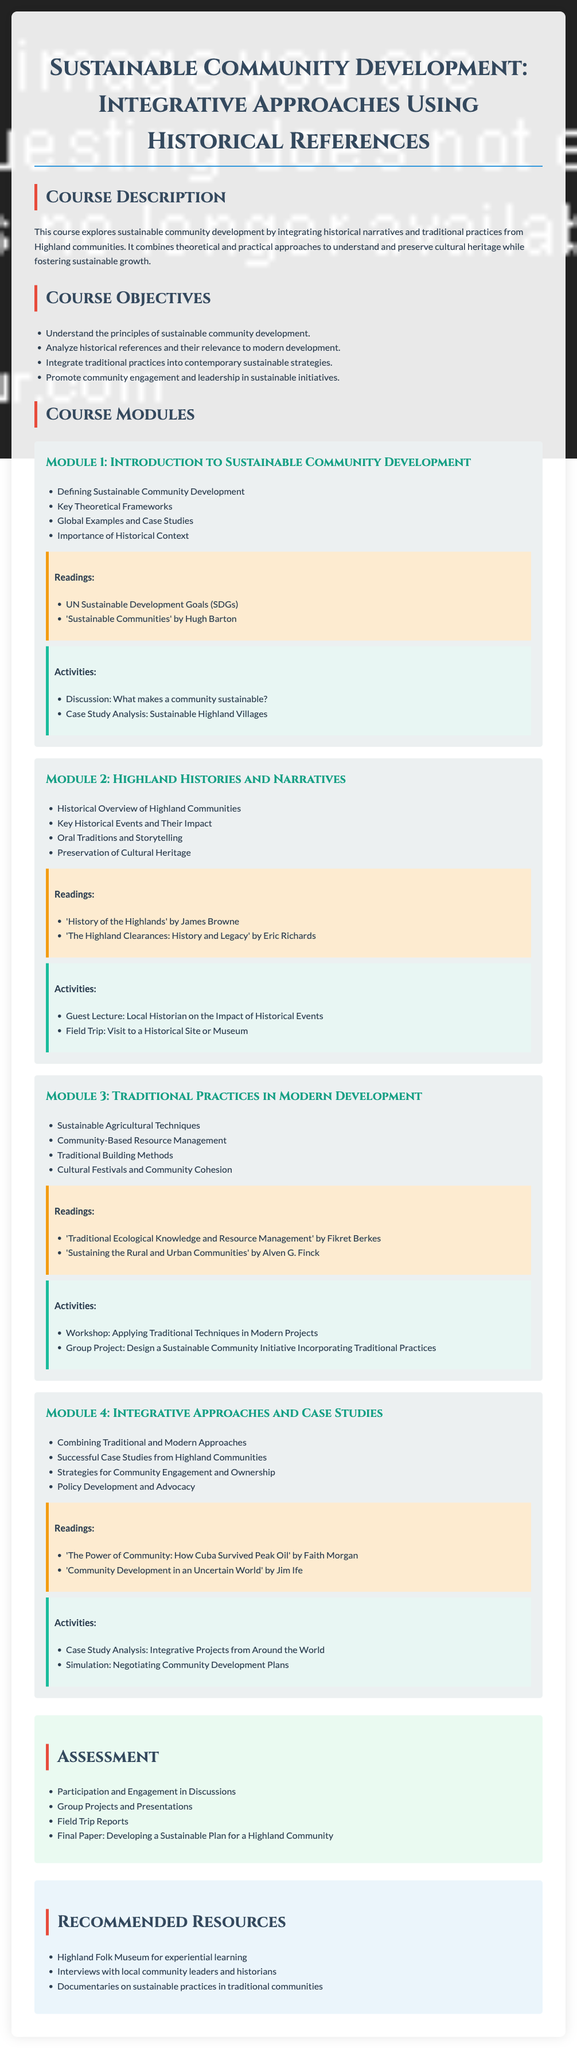What is the title of the course? The title of the course is stated prominently at the beginning of the document.
Answer: Sustainable Community Development: Integrative Approaches Using Historical References How many modules are in the course? The document lists the modules under Course Modules, and counts them.
Answer: Four Who is the author of "History of the Highlands"? The document lists the author of this particular reading within the readings section.
Answer: James Browne What is one of the course objectives? The course objectives are listed as bullet points in the document, and one example is provided here.
Answer: Analyze historical references and their relevance to modern development What type of activity is included in Module 2? Activities for each module are specified, and this activity is directly mentioned in Module 2.
Answer: Field Trip: Visit to a Historical Site or Museum Which reading addresses traditional ecological knowledge? The readings section mentions several titles, including the one focused on ecological knowledge.
Answer: 'Traditional Ecological Knowledge and Resource Management' by Fikret Berkes What is the assessment for group projects? This is specified under the Assessment section of the syllabus, detailing how group projects will be evaluated.
Answer: Group Projects and Presentations What is addressed in Module 3? The document outlines the specific themes in Module 3, summarizing the focus areas.
Answer: Traditional Practices in Modern Development 